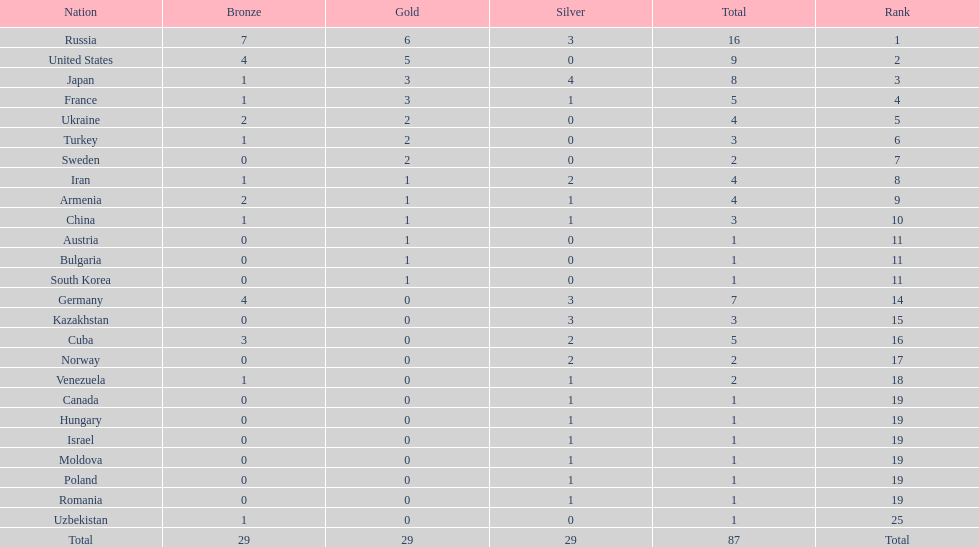Who won more gold medals than the united states? Russia. Would you be able to parse every entry in this table? {'header': ['Nation', 'Bronze', 'Gold', 'Silver', 'Total', 'Rank'], 'rows': [['Russia', '7', '6', '3', '16', '1'], ['United States', '4', '5', '0', '9', '2'], ['Japan', '1', '3', '4', '8', '3'], ['France', '1', '3', '1', '5', '4'], ['Ukraine', '2', '2', '0', '4', '5'], ['Turkey', '1', '2', '0', '3', '6'], ['Sweden', '0', '2', '0', '2', '7'], ['Iran', '1', '1', '2', '4', '8'], ['Armenia', '2', '1', '1', '4', '9'], ['China', '1', '1', '1', '3', '10'], ['Austria', '0', '1', '0', '1', '11'], ['Bulgaria', '0', '1', '0', '1', '11'], ['South Korea', '0', '1', '0', '1', '11'], ['Germany', '4', '0', '3', '7', '14'], ['Kazakhstan', '0', '0', '3', '3', '15'], ['Cuba', '3', '0', '2', '5', '16'], ['Norway', '0', '0', '2', '2', '17'], ['Venezuela', '1', '0', '1', '2', '18'], ['Canada', '0', '0', '1', '1', '19'], ['Hungary', '0', '0', '1', '1', '19'], ['Israel', '0', '0', '1', '1', '19'], ['Moldova', '0', '0', '1', '1', '19'], ['Poland', '0', '0', '1', '1', '19'], ['Romania', '0', '0', '1', '1', '19'], ['Uzbekistan', '1', '0', '0', '1', '25'], ['Total', '29', '29', '29', '87', 'Total']]} 